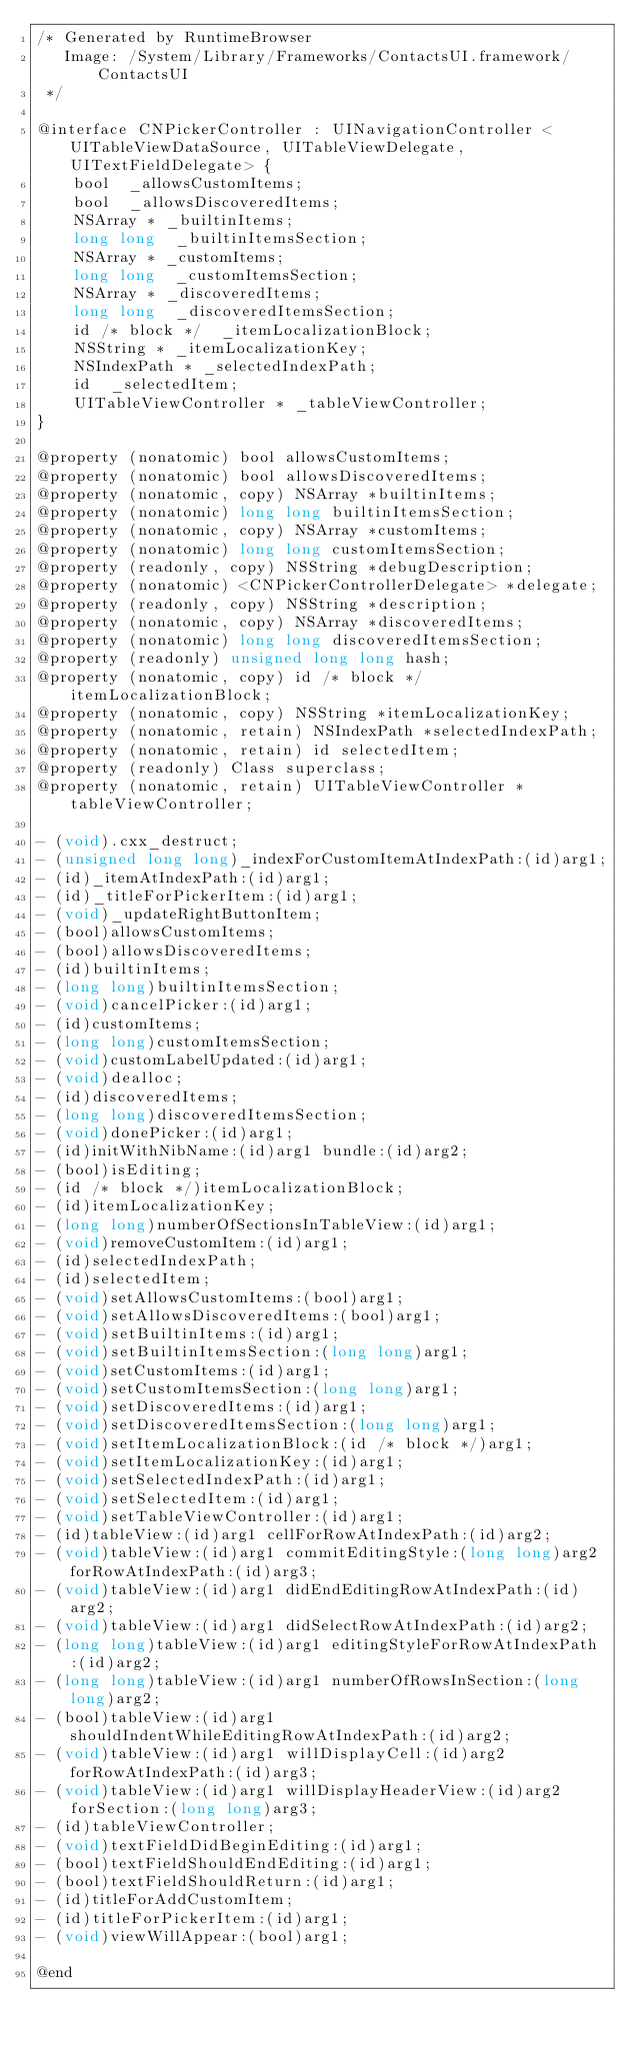Convert code to text. <code><loc_0><loc_0><loc_500><loc_500><_C_>/* Generated by RuntimeBrowser
   Image: /System/Library/Frameworks/ContactsUI.framework/ContactsUI
 */

@interface CNPickerController : UINavigationController <UITableViewDataSource, UITableViewDelegate, UITextFieldDelegate> {
    bool  _allowsCustomItems;
    bool  _allowsDiscoveredItems;
    NSArray * _builtinItems;
    long long  _builtinItemsSection;
    NSArray * _customItems;
    long long  _customItemsSection;
    NSArray * _discoveredItems;
    long long  _discoveredItemsSection;
    id /* block */  _itemLocalizationBlock;
    NSString * _itemLocalizationKey;
    NSIndexPath * _selectedIndexPath;
    id  _selectedItem;
    UITableViewController * _tableViewController;
}

@property (nonatomic) bool allowsCustomItems;
@property (nonatomic) bool allowsDiscoveredItems;
@property (nonatomic, copy) NSArray *builtinItems;
@property (nonatomic) long long builtinItemsSection;
@property (nonatomic, copy) NSArray *customItems;
@property (nonatomic) long long customItemsSection;
@property (readonly, copy) NSString *debugDescription;
@property (nonatomic) <CNPickerControllerDelegate> *delegate;
@property (readonly, copy) NSString *description;
@property (nonatomic, copy) NSArray *discoveredItems;
@property (nonatomic) long long discoveredItemsSection;
@property (readonly) unsigned long long hash;
@property (nonatomic, copy) id /* block */ itemLocalizationBlock;
@property (nonatomic, copy) NSString *itemLocalizationKey;
@property (nonatomic, retain) NSIndexPath *selectedIndexPath;
@property (nonatomic, retain) id selectedItem;
@property (readonly) Class superclass;
@property (nonatomic, retain) UITableViewController *tableViewController;

- (void).cxx_destruct;
- (unsigned long long)_indexForCustomItemAtIndexPath:(id)arg1;
- (id)_itemAtIndexPath:(id)arg1;
- (id)_titleForPickerItem:(id)arg1;
- (void)_updateRightButtonItem;
- (bool)allowsCustomItems;
- (bool)allowsDiscoveredItems;
- (id)builtinItems;
- (long long)builtinItemsSection;
- (void)cancelPicker:(id)arg1;
- (id)customItems;
- (long long)customItemsSection;
- (void)customLabelUpdated:(id)arg1;
- (void)dealloc;
- (id)discoveredItems;
- (long long)discoveredItemsSection;
- (void)donePicker:(id)arg1;
- (id)initWithNibName:(id)arg1 bundle:(id)arg2;
- (bool)isEditing;
- (id /* block */)itemLocalizationBlock;
- (id)itemLocalizationKey;
- (long long)numberOfSectionsInTableView:(id)arg1;
- (void)removeCustomItem:(id)arg1;
- (id)selectedIndexPath;
- (id)selectedItem;
- (void)setAllowsCustomItems:(bool)arg1;
- (void)setAllowsDiscoveredItems:(bool)arg1;
- (void)setBuiltinItems:(id)arg1;
- (void)setBuiltinItemsSection:(long long)arg1;
- (void)setCustomItems:(id)arg1;
- (void)setCustomItemsSection:(long long)arg1;
- (void)setDiscoveredItems:(id)arg1;
- (void)setDiscoveredItemsSection:(long long)arg1;
- (void)setItemLocalizationBlock:(id /* block */)arg1;
- (void)setItemLocalizationKey:(id)arg1;
- (void)setSelectedIndexPath:(id)arg1;
- (void)setSelectedItem:(id)arg1;
- (void)setTableViewController:(id)arg1;
- (id)tableView:(id)arg1 cellForRowAtIndexPath:(id)arg2;
- (void)tableView:(id)arg1 commitEditingStyle:(long long)arg2 forRowAtIndexPath:(id)arg3;
- (void)tableView:(id)arg1 didEndEditingRowAtIndexPath:(id)arg2;
- (void)tableView:(id)arg1 didSelectRowAtIndexPath:(id)arg2;
- (long long)tableView:(id)arg1 editingStyleForRowAtIndexPath:(id)arg2;
- (long long)tableView:(id)arg1 numberOfRowsInSection:(long long)arg2;
- (bool)tableView:(id)arg1 shouldIndentWhileEditingRowAtIndexPath:(id)arg2;
- (void)tableView:(id)arg1 willDisplayCell:(id)arg2 forRowAtIndexPath:(id)arg3;
- (void)tableView:(id)arg1 willDisplayHeaderView:(id)arg2 forSection:(long long)arg3;
- (id)tableViewController;
- (void)textFieldDidBeginEditing:(id)arg1;
- (bool)textFieldShouldEndEditing:(id)arg1;
- (bool)textFieldShouldReturn:(id)arg1;
- (id)titleForAddCustomItem;
- (id)titleForPickerItem:(id)arg1;
- (void)viewWillAppear:(bool)arg1;

@end
</code> 